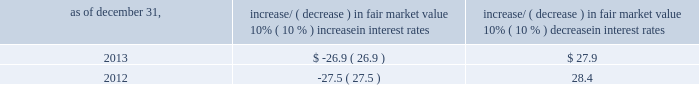Item 7a .
Quantitative and qualitative disclosures about market risk ( amounts in millions ) in the normal course of business , we are exposed to market risks related to interest rates , foreign currency rates and certain balance sheet items .
From time to time , we use derivative instruments , pursuant to established guidelines and policies , to manage some portion of these risks .
Derivative instruments utilized in our hedging activities are viewed as risk management tools and are not used for trading or speculative purposes .
Interest rates our exposure to market risk for changes in interest rates relates primarily to the fair market value and cash flows of our debt obligations .
The majority of our debt ( approximately 89% ( 89 % ) and 93% ( 93 % ) as of december 31 , 2013 and 2012 , respectively ) bears interest at fixed rates .
We do have debt with variable interest rates , but a 10% ( 10 % ) increase or decrease in interest rates would not be material to our interest expense or cash flows .
The fair market value of our debt is sensitive to changes in interest rates , and the impact of a 10% ( 10 % ) change in interest rates is summarized below .
Increase/ ( decrease ) in fair market value as of december 31 , 10% ( 10 % ) increase in interest rates 10% ( 10 % ) decrease in interest rates .
We have used interest rate swaps for risk management purposes to manage our exposure to changes in interest rates .
We do not have any interest rate swaps outstanding as of december 31 , 2013 .
We had $ 1642.1 of cash , cash equivalents and marketable securities as of december 31 , 2013 that we generally invest in conservative , short-term bank deposits or securities .
The interest income generated from these investments is subject to both domestic and foreign interest rate movements .
During 2013 and 2012 , we had interest income of $ 24.7 and $ 29.5 , respectively .
Based on our 2013 results , a 100-basis-point increase or decrease in interest rates would affect our interest income by approximately $ 16.4 , assuming that all cash , cash equivalents and marketable securities are impacted in the same manner and balances remain constant from year-end 2013 levels .
Foreign currency rates we are subject to translation and transaction risks related to changes in foreign currency exchange rates .
Since we report revenues and expenses in u.s .
Dollars , changes in exchange rates may either positively or negatively affect our consolidated revenues and expenses ( as expressed in u.s .
Dollars ) from foreign operations .
The primary foreign currencies that impacted our results during 2013 were the australian dollar , brazilian real , euro , japanese yen and the south african rand .
Based on 2013 exchange rates and operating results , if the u.s .
Dollar were to strengthen or weaken by 10% ( 10 % ) , we currently estimate operating income would decrease or increase between 3% ( 3 % ) and 4% ( 4 % ) , assuming that all currencies are impacted in the same manner and our international revenue and expenses remain constant at 2013 levels .
The functional currency of our foreign operations is generally their respective local currency .
Assets and liabilities are translated at the exchange rates in effect at the balance sheet date , and revenues and expenses are translated at the average exchange rates during the period presented .
The resulting translation adjustments are recorded as a component of accumulated other comprehensive loss , net of tax , in the stockholders 2019 equity section of our consolidated balance sheets .
Our foreign subsidiaries generally collect revenues and pay expenses in their functional currency , mitigating transaction risk .
However , certain subsidiaries may enter into transactions in currencies other than their functional currency .
Assets and liabilities denominated in currencies other than the functional currency are susceptible to movements in foreign currency until final settlement .
Currency transaction gains or losses primarily arising from transactions in currencies other than the functional currency are included in office and general expenses .
We have not entered into a material amount of foreign currency forward exchange contracts or other derivative financial instruments to hedge the effects of potential adverse fluctuations in foreign currency exchange rates. .
Assuming that all the balance of cash and cash equivalents and marketable securities is invested to generate the given interest income , what would be the average return of these investments in 2013? 
Computations: (24.7 / 1642.1)
Answer: 0.01504. Item 7a .
Quantitative and qualitative disclosures about market risk ( amounts in millions ) in the normal course of business , we are exposed to market risks related to interest rates , foreign currency rates and certain balance sheet items .
From time to time , we use derivative instruments , pursuant to established guidelines and policies , to manage some portion of these risks .
Derivative instruments utilized in our hedging activities are viewed as risk management tools and are not used for trading or speculative purposes .
Interest rates our exposure to market risk for changes in interest rates relates primarily to the fair market value and cash flows of our debt obligations .
The majority of our debt ( approximately 89% ( 89 % ) and 93% ( 93 % ) as of december 31 , 2013 and 2012 , respectively ) bears interest at fixed rates .
We do have debt with variable interest rates , but a 10% ( 10 % ) increase or decrease in interest rates would not be material to our interest expense or cash flows .
The fair market value of our debt is sensitive to changes in interest rates , and the impact of a 10% ( 10 % ) change in interest rates is summarized below .
Increase/ ( decrease ) in fair market value as of december 31 , 10% ( 10 % ) increase in interest rates 10% ( 10 % ) decrease in interest rates .
We have used interest rate swaps for risk management purposes to manage our exposure to changes in interest rates .
We do not have any interest rate swaps outstanding as of december 31 , 2013 .
We had $ 1642.1 of cash , cash equivalents and marketable securities as of december 31 , 2013 that we generally invest in conservative , short-term bank deposits or securities .
The interest income generated from these investments is subject to both domestic and foreign interest rate movements .
During 2013 and 2012 , we had interest income of $ 24.7 and $ 29.5 , respectively .
Based on our 2013 results , a 100-basis-point increase or decrease in interest rates would affect our interest income by approximately $ 16.4 , assuming that all cash , cash equivalents and marketable securities are impacted in the same manner and balances remain constant from year-end 2013 levels .
Foreign currency rates we are subject to translation and transaction risks related to changes in foreign currency exchange rates .
Since we report revenues and expenses in u.s .
Dollars , changes in exchange rates may either positively or negatively affect our consolidated revenues and expenses ( as expressed in u.s .
Dollars ) from foreign operations .
The primary foreign currencies that impacted our results during 2013 were the australian dollar , brazilian real , euro , japanese yen and the south african rand .
Based on 2013 exchange rates and operating results , if the u.s .
Dollar were to strengthen or weaken by 10% ( 10 % ) , we currently estimate operating income would decrease or increase between 3% ( 3 % ) and 4% ( 4 % ) , assuming that all currencies are impacted in the same manner and our international revenue and expenses remain constant at 2013 levels .
The functional currency of our foreign operations is generally their respective local currency .
Assets and liabilities are translated at the exchange rates in effect at the balance sheet date , and revenues and expenses are translated at the average exchange rates during the period presented .
The resulting translation adjustments are recorded as a component of accumulated other comprehensive loss , net of tax , in the stockholders 2019 equity section of our consolidated balance sheets .
Our foreign subsidiaries generally collect revenues and pay expenses in their functional currency , mitigating transaction risk .
However , certain subsidiaries may enter into transactions in currencies other than their functional currency .
Assets and liabilities denominated in currencies other than the functional currency are susceptible to movements in foreign currency until final settlement .
Currency transaction gains or losses primarily arising from transactions in currencies other than the functional currency are included in office and general expenses .
We have not entered into a material amount of foreign currency forward exchange contracts or other derivative financial instruments to hedge the effects of potential adverse fluctuations in foreign currency exchange rates. .
What is the growth rate of the interest income from 2012 to 2013? 
Computations: ((24.7 - 29.5) / 29.5)
Answer: -0.16271. 